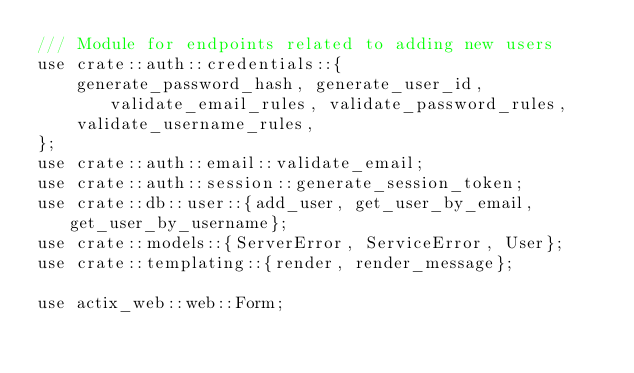Convert code to text. <code><loc_0><loc_0><loc_500><loc_500><_Rust_>/// Module for endpoints related to adding new users
use crate::auth::credentials::{
    generate_password_hash, generate_user_id, validate_email_rules, validate_password_rules,
    validate_username_rules,
};
use crate::auth::email::validate_email;
use crate::auth::session::generate_session_token;
use crate::db::user::{add_user, get_user_by_email, get_user_by_username};
use crate::models::{ServerError, ServiceError, User};
use crate::templating::{render, render_message};

use actix_web::web::Form;</code> 